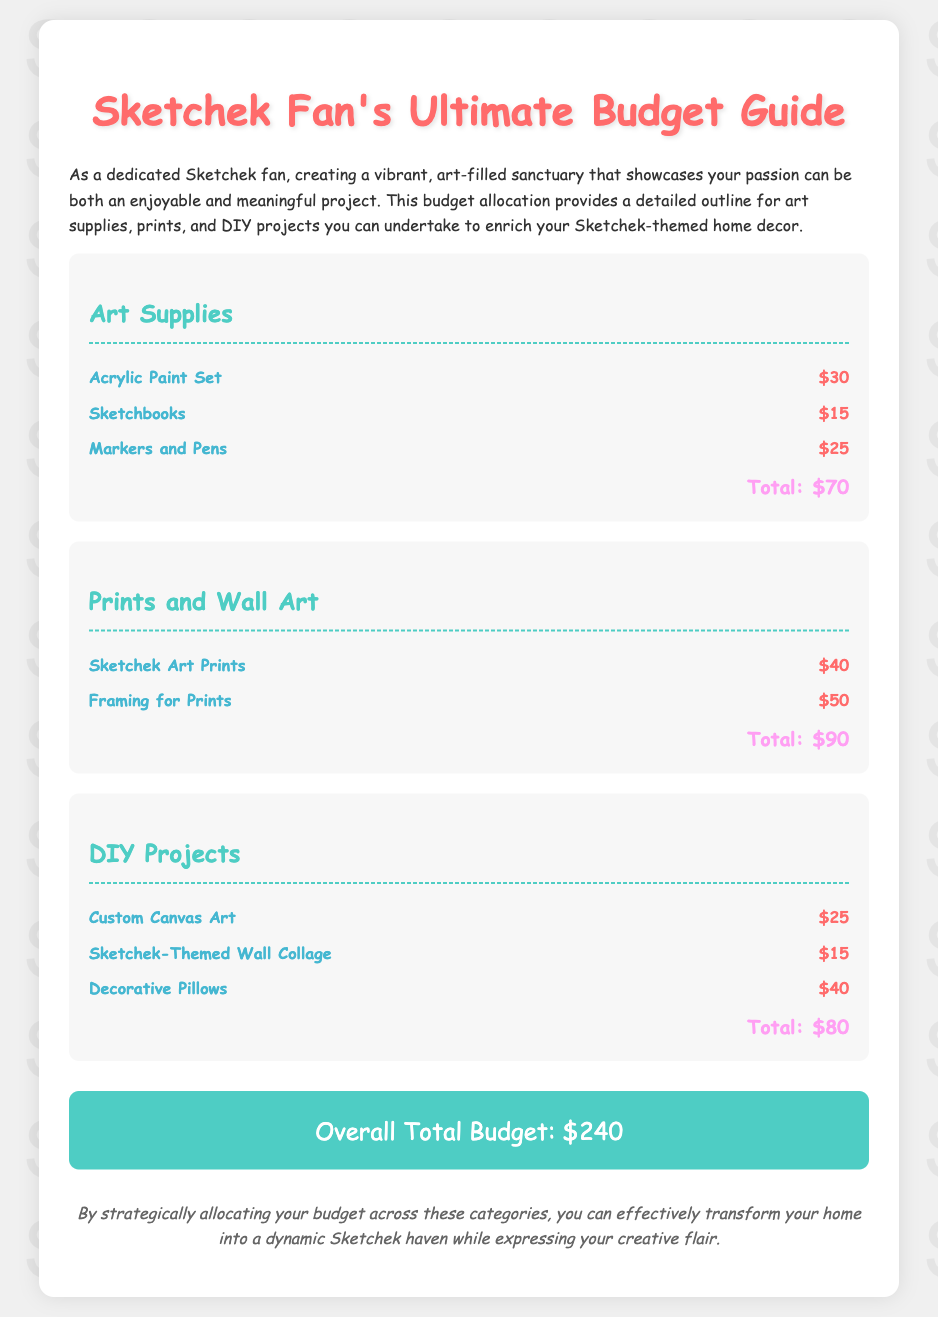What is the total cost of art supplies? The total cost of art supplies is directly provided in the document's art supplies section.
Answer: $70 What is the cost of Sketchek art prints? The cost of Sketchek art prints is listed in the prints and wall art category.
Answer: $40 How much is allocated for decorative pillows? The allocation for decorative pillows is specified in the DIY projects section.
Answer: $40 What is the overall total budget? The overall total budget is the sum of all category totals, presented at the bottom of the document.
Answer: $240 How much does framing for prints cost? The cost for framing prints is explicitly mentioned in the prints and wall art category.
Answer: $50 What is the total budget allocated for DIY projects? The total budget for DIY projects is given within its category total.
Answer: $80 What is the cost of markers and pens? The cost for markers and pens is listed in the art supplies section of the document.
Answer: $25 Which art supply has the highest cost? To identify the highest cost, compare individual costs listed in the art supplies section.
Answer: Acrylic Paint Set What is the total cost of prints and wall art? The total cost for prints and wall art is provided in the designated category.
Answer: $90 